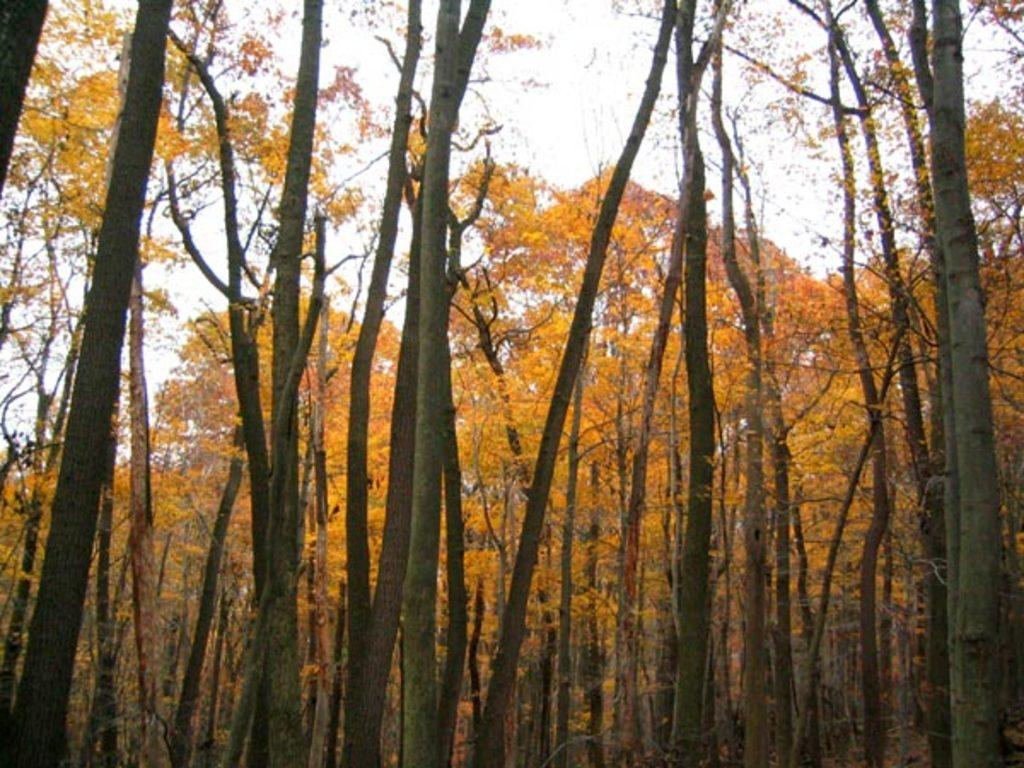What type of vegetation is in the middle of the image? There are trees in the middle of the image. What can be seen in the background of the image? The sky is visible in the background of the image. What type of skirt is hanging in the shop in the image? There is no shop or skirt present in the image; it only features trees and the sky. 